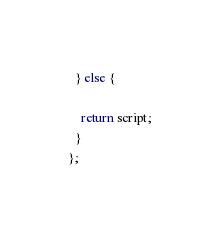Convert code to text. <code><loc_0><loc_0><loc_500><loc_500><_JavaScript_>  } else {

    return script;
  }
};</code> 